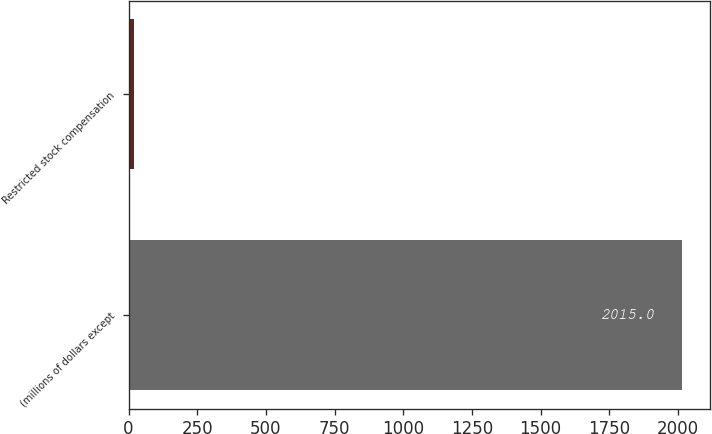Convert chart to OTSL. <chart><loc_0><loc_0><loc_500><loc_500><bar_chart><fcel>(millions of dollars except<fcel>Restricted stock compensation<nl><fcel>2015<fcel>20.4<nl></chart> 